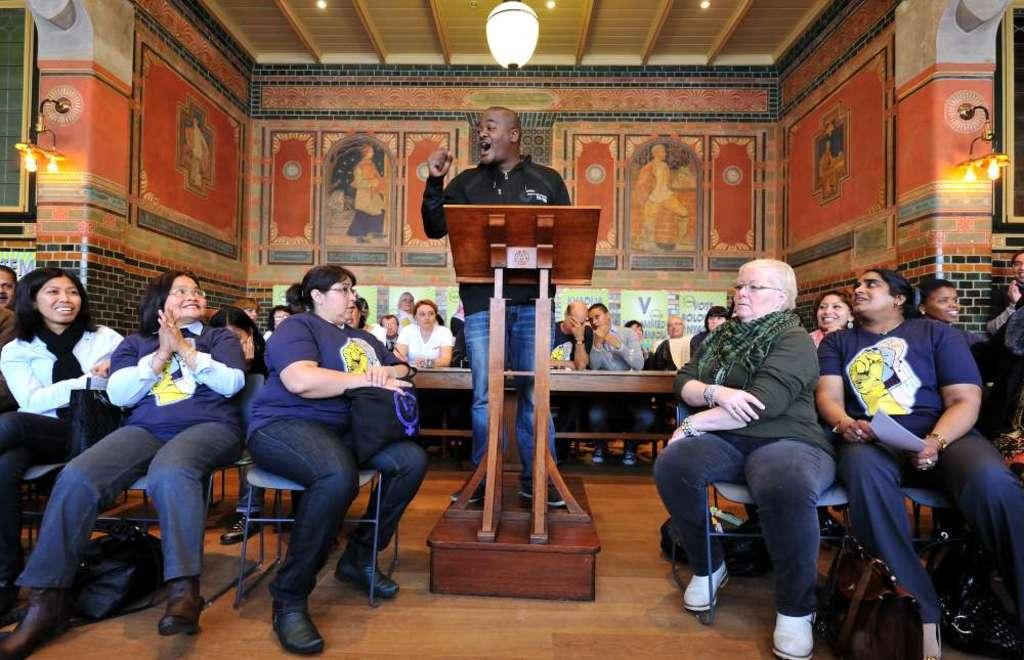How many people are in the image? There is a group of people in the image. What are the people doing in the image? The people are sitting on chairs and benches. What is the man at the podium doing? The man is standing at a podium and talking. What can be seen in the background of the image? There are lights and a wall visible in the background. What type of advertisement is being displayed on the wall in the image? There is no advertisement present on the wall in the image; it is a plain wall. 